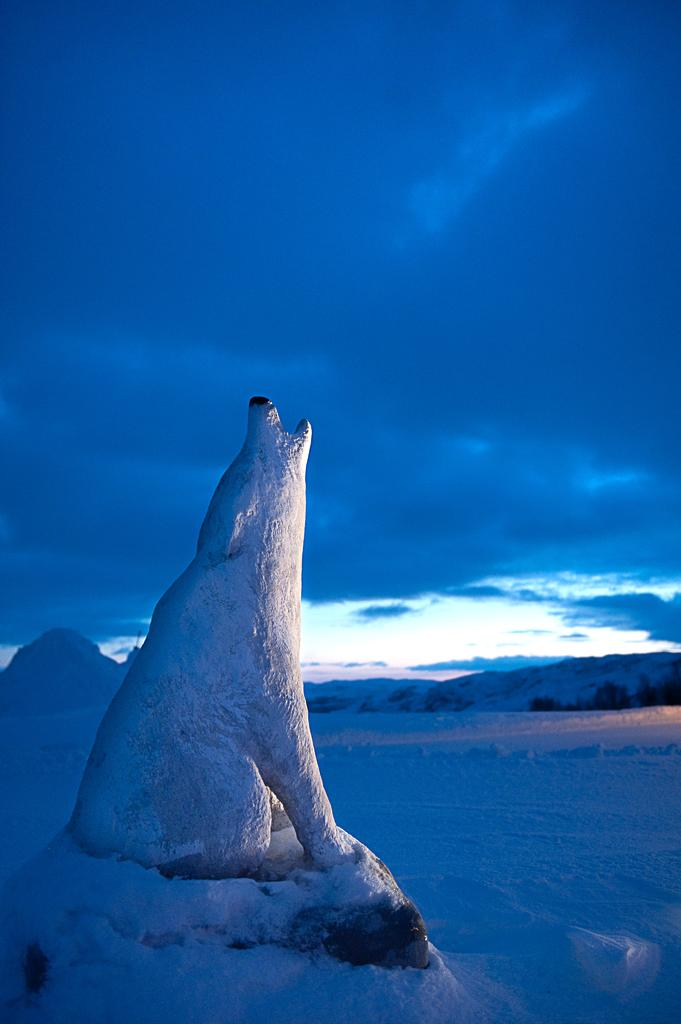What animal is the main subject of the picture? There is a white polar bear in the picture. What is the polar bear doing in the image? The polar bear is sitting on a snow rock and roaring. What type of terrain is visible in the background? There is snow on the ground in the background. What can be seen in the sky in the image? The sky is visible in the image, and clouds are present. What color is the crayon that the polar bear is holding in the image? There is no crayon present in the image; the polar bear is roaring and sitting on a snow rock. Can you see a tree in the background of the image? There is no tree visible in the image; the background terrain consists of snowy ground. 